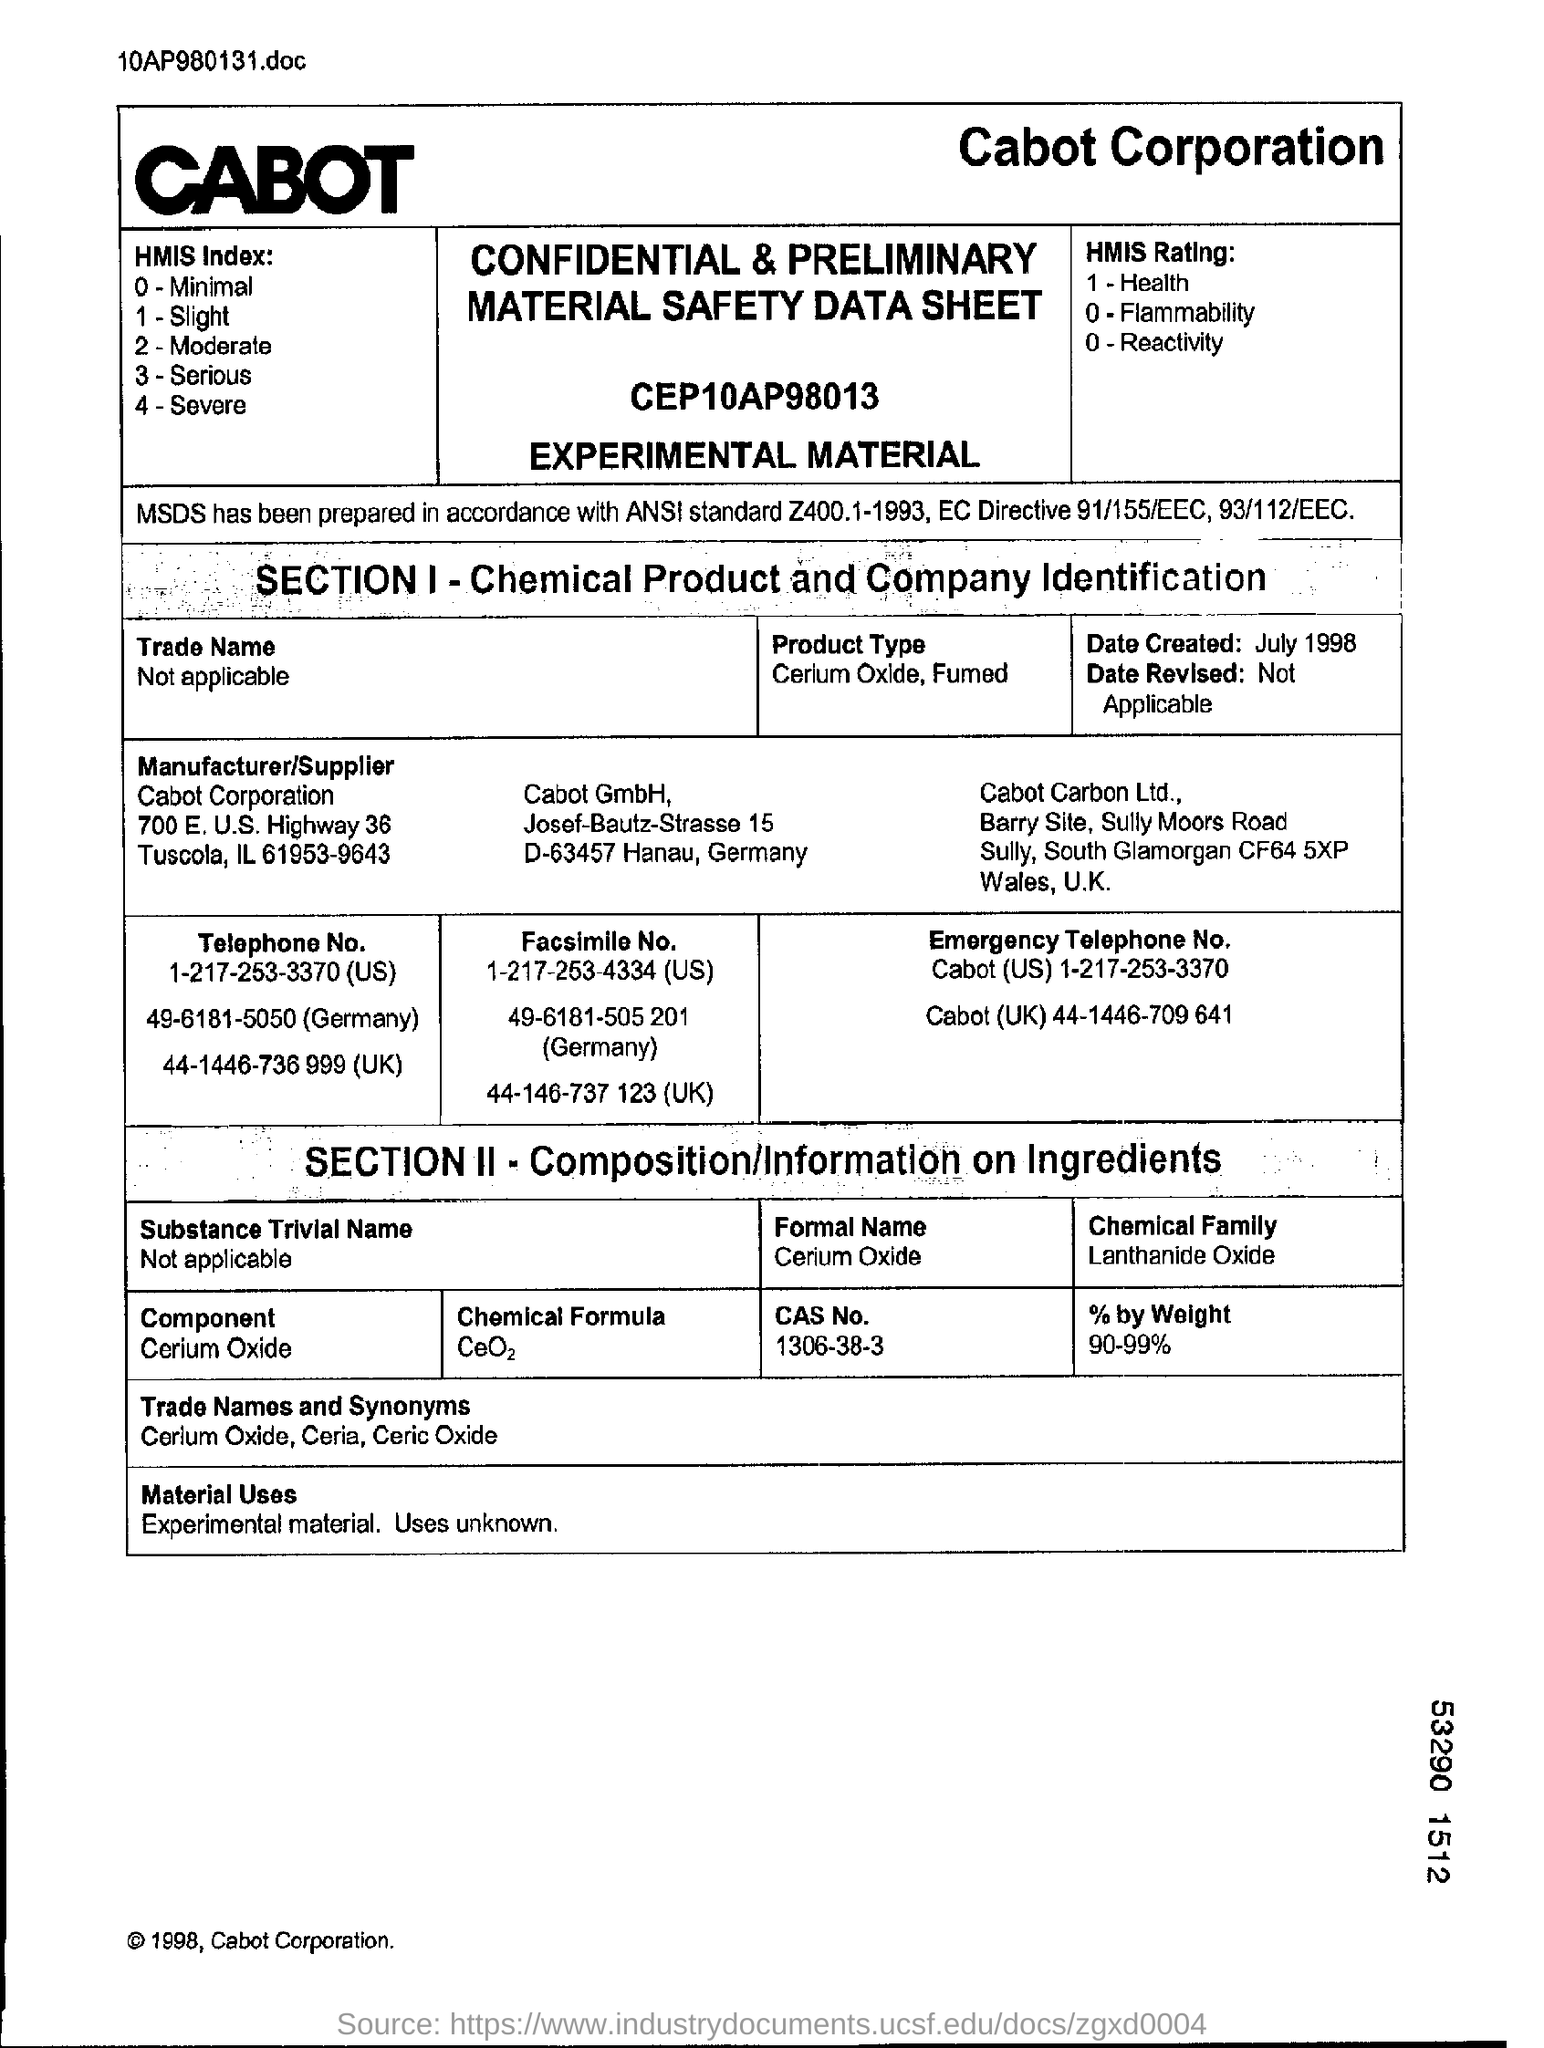Draw attention to some important aspects in this diagram. The chemical formula of cerium oxide is CeO2. The emergency telephone number for Cabot in the UK is 44-1446-709 641. Cerium oxide is the component mentioned in section 2. 